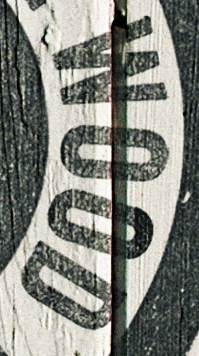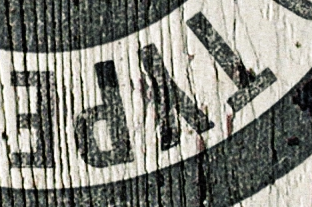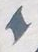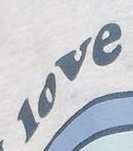What words are shown in these images in order, separated by a semicolon? WOOD; TYPE; I; love 